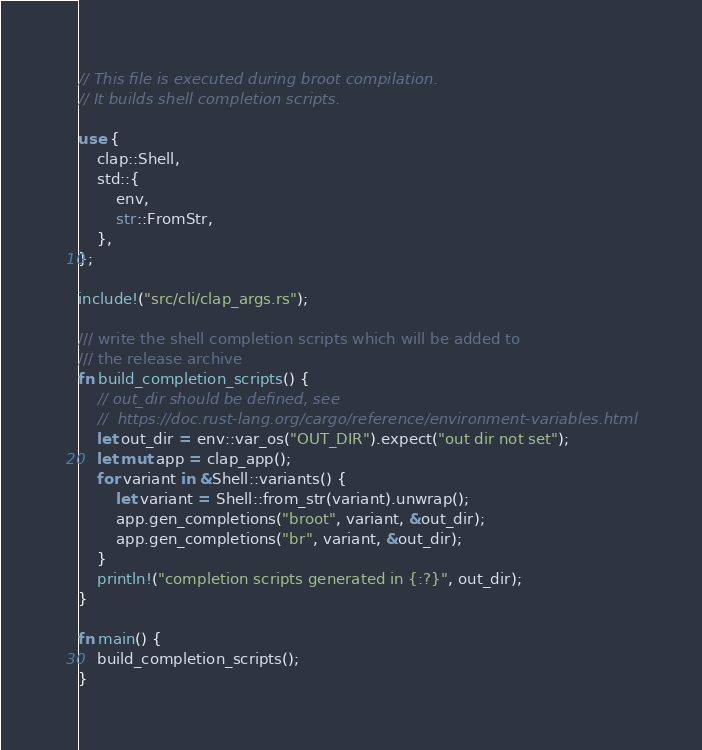Convert code to text. <code><loc_0><loc_0><loc_500><loc_500><_Rust_>// This file is executed during broot compilation.
// It builds shell completion scripts.

use {
    clap::Shell,
    std::{
        env,
        str::FromStr,
    },
};

include!("src/cli/clap_args.rs");

/// write the shell completion scripts which will be added to
/// the release archive
fn build_completion_scripts() {
    // out_dir should be defined, see
    //  https://doc.rust-lang.org/cargo/reference/environment-variables.html
    let out_dir = env::var_os("OUT_DIR").expect("out dir not set");
    let mut app = clap_app();
    for variant in &Shell::variants() {
        let variant = Shell::from_str(variant).unwrap();
        app.gen_completions("broot", variant, &out_dir);
        app.gen_completions("br", variant, &out_dir);
    }
    println!("completion scripts generated in {:?}", out_dir);
}

fn main() {
    build_completion_scripts();
}
</code> 